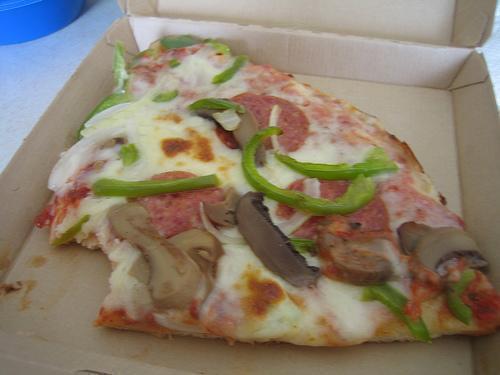How many slices of pizza are there?
Give a very brief answer. 1. 